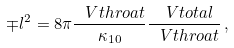<formula> <loc_0><loc_0><loc_500><loc_500>\mp l ^ { 2 } = 8 \pi \frac { \ V t h r o a t } { \kappa _ { 1 0 } } \frac { \ V t o t a l } { \ V t h r o a t } \, ,</formula> 